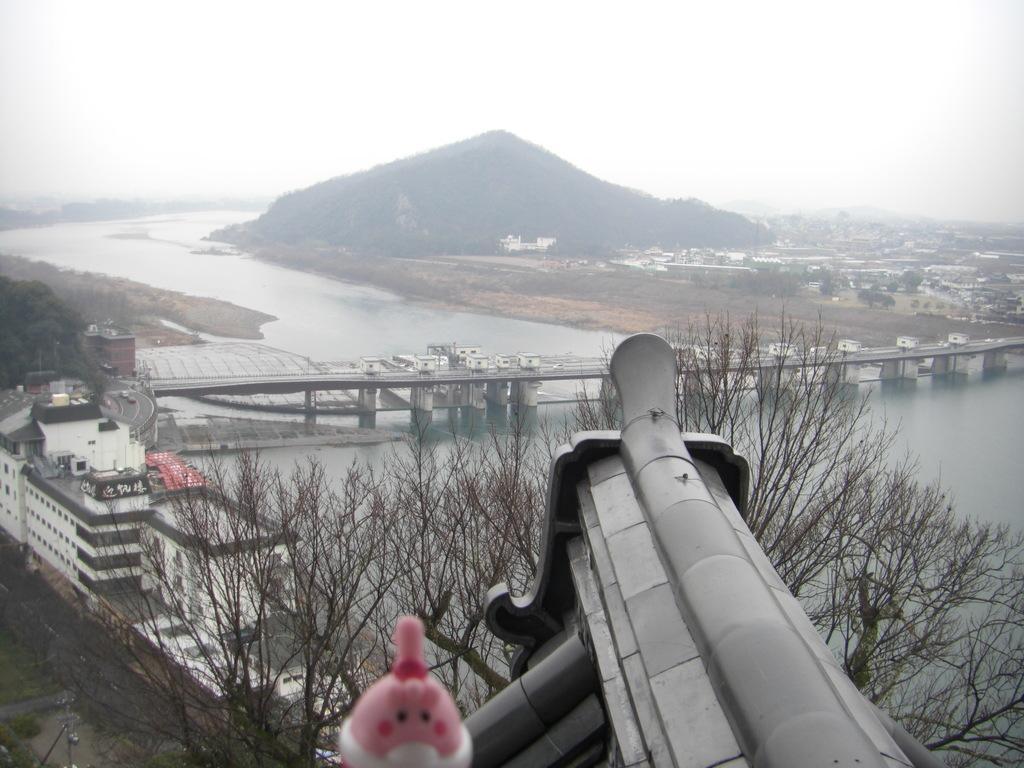How would you summarize this image in a sentence or two? In this picture we can see few trees and buildings, and also we can see a bridge over the water, in the background we can find a hill. 